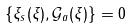Convert formula to latex. <formula><loc_0><loc_0><loc_500><loc_500>\{ \xi _ { s } ( \xi ) , \mathcal { G } _ { a } ( \xi ) \} = 0</formula> 